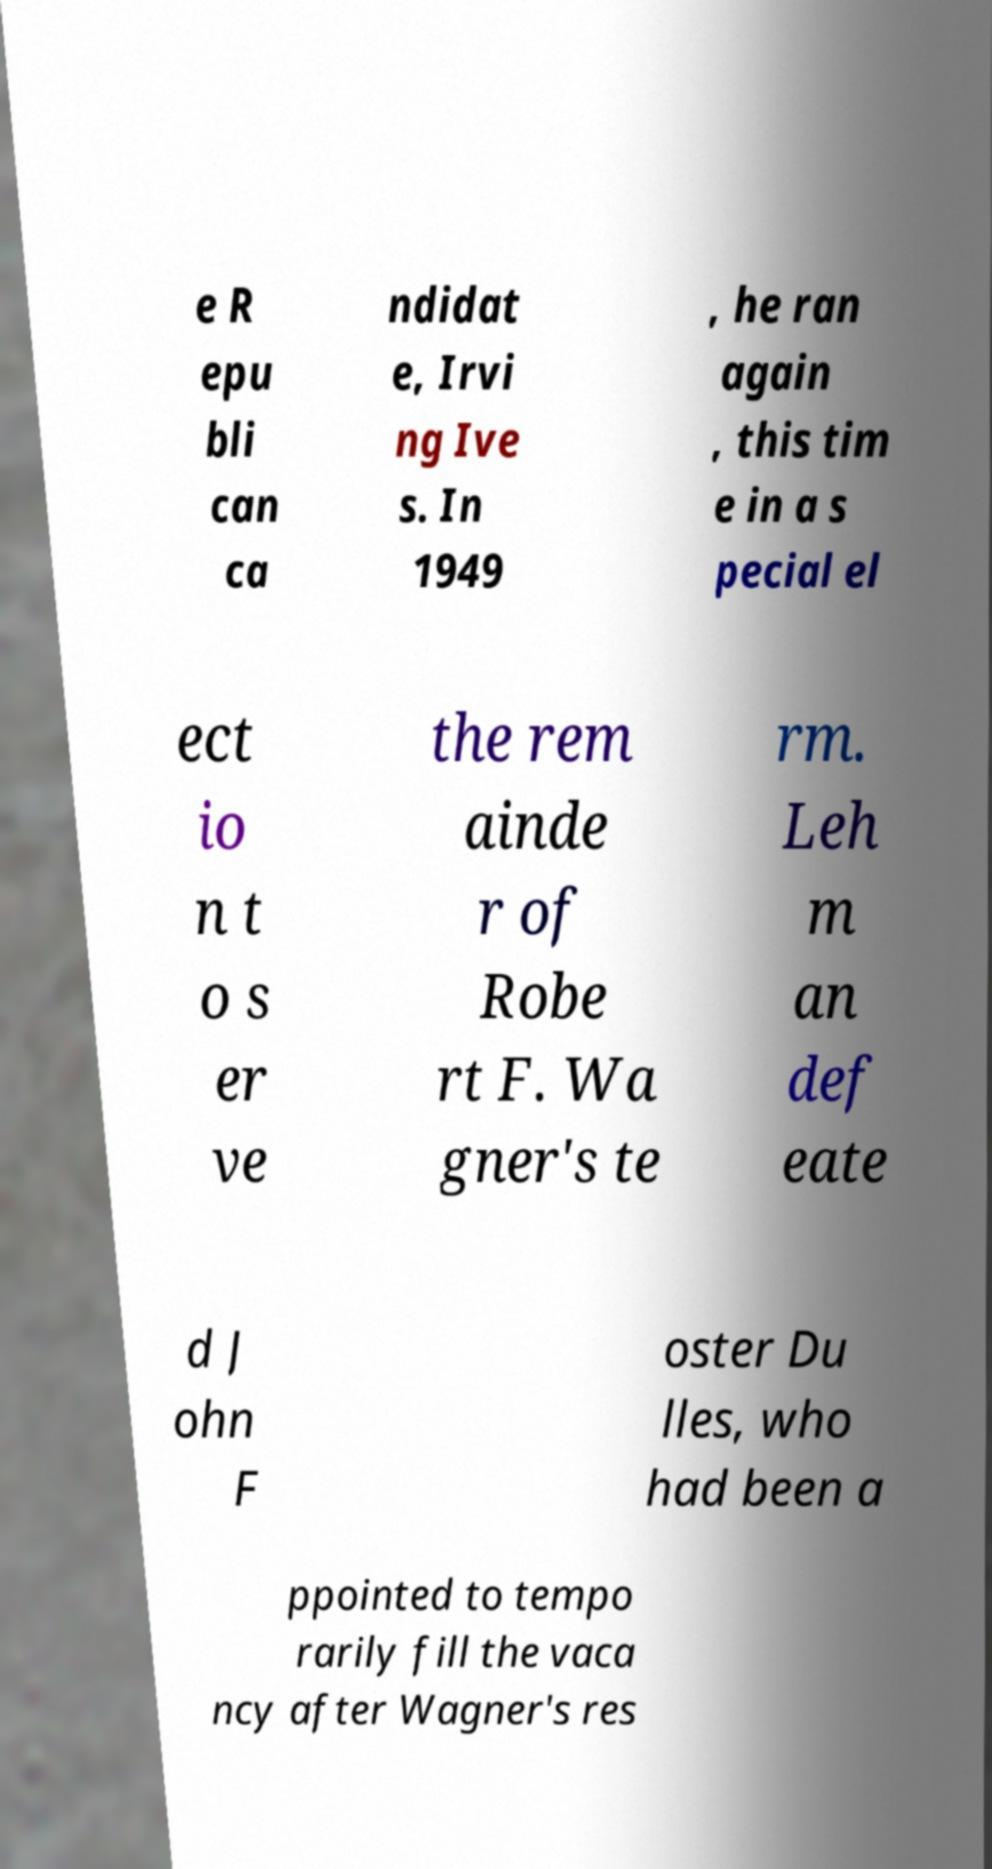What messages or text are displayed in this image? I need them in a readable, typed format. e R epu bli can ca ndidat e, Irvi ng Ive s. In 1949 , he ran again , this tim e in a s pecial el ect io n t o s er ve the rem ainde r of Robe rt F. Wa gner's te rm. Leh m an def eate d J ohn F oster Du lles, who had been a ppointed to tempo rarily fill the vaca ncy after Wagner's res 